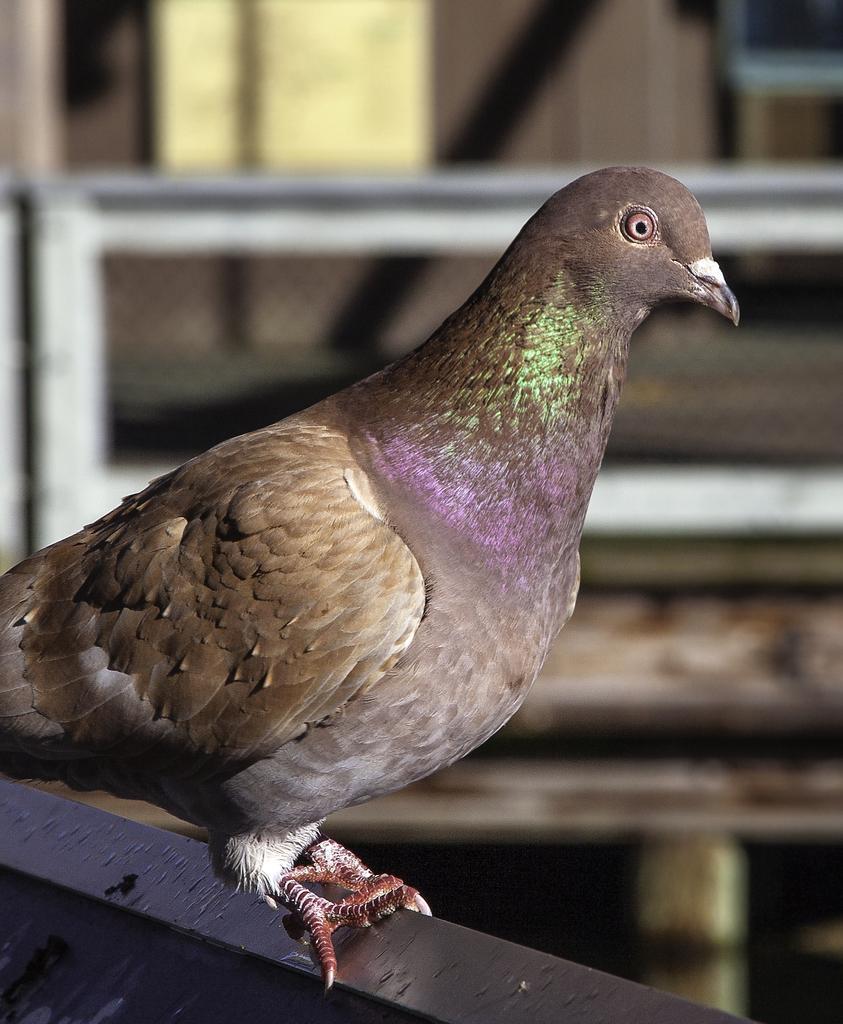In one or two sentences, can you explain what this image depicts? This is the picture of a bird which is on the black thing and behind there are some other things. 